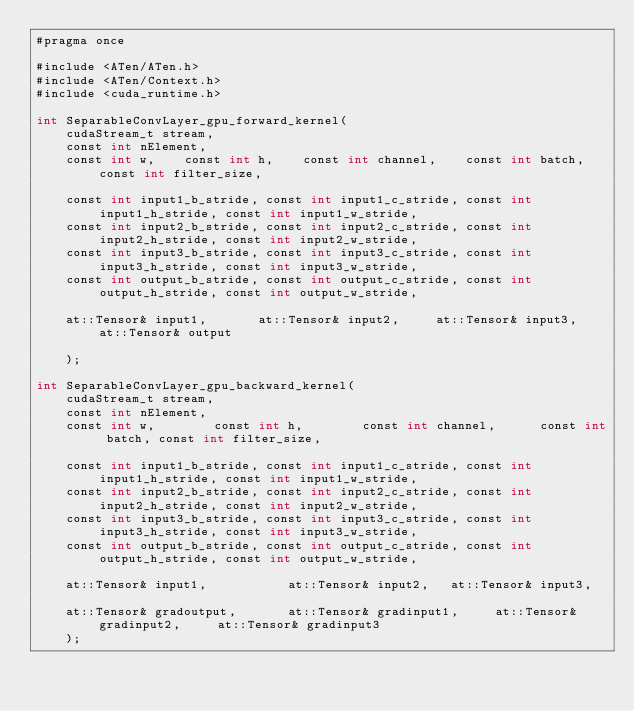Convert code to text. <code><loc_0><loc_0><loc_500><loc_500><_Cuda_>#pragma once

#include <ATen/ATen.h>
#include <ATen/Context.h>
#include <cuda_runtime.h>

int SeparableConvLayer_gpu_forward_kernel(
		cudaStream_t stream,
		const int nElement,
		const int w, 		const int h, 		const int channel, 		const int batch, const int filter_size,

		const int input1_b_stride, const int input1_c_stride, const int input1_h_stride, const int input1_w_stride,
		const int input2_b_stride, const int input2_c_stride, const int input2_h_stride, const int input2_w_stride,
		const int input3_b_stride, const int input3_c_stride, const int input3_h_stride, const int input3_w_stride,
		const int output_b_stride, const int output_c_stride, const int output_h_stride, const int output_w_stride,

		at::Tensor& input1,    		at::Tensor& input2,    	at::Tensor& input3, 	at::Tensor& output

		);

int SeparableConvLayer_gpu_backward_kernel(
		cudaStream_t stream,
		const int nElement,
		const int w,    		const int h,    		const int channel,  		const int batch, const int filter_size,

		const int input1_b_stride, const int input1_c_stride, const int input1_h_stride, const int input1_w_stride,
		const int input2_b_stride, const int input2_c_stride, const int input2_h_stride, const int input2_w_stride,
		const int input3_b_stride, const int input3_c_stride, const int input3_h_stride, const int input3_w_stride,
		const int output_b_stride, const int output_c_stride, const int output_h_stride, const int output_w_stride,

		at::Tensor& input1,        		at::Tensor& input2,		at::Tensor& input3,

		at::Tensor& gradoutput,    		at::Tensor& gradinput1,  		at::Tensor& gradinput2,  		at::Tensor& gradinput3
		);
</code> 